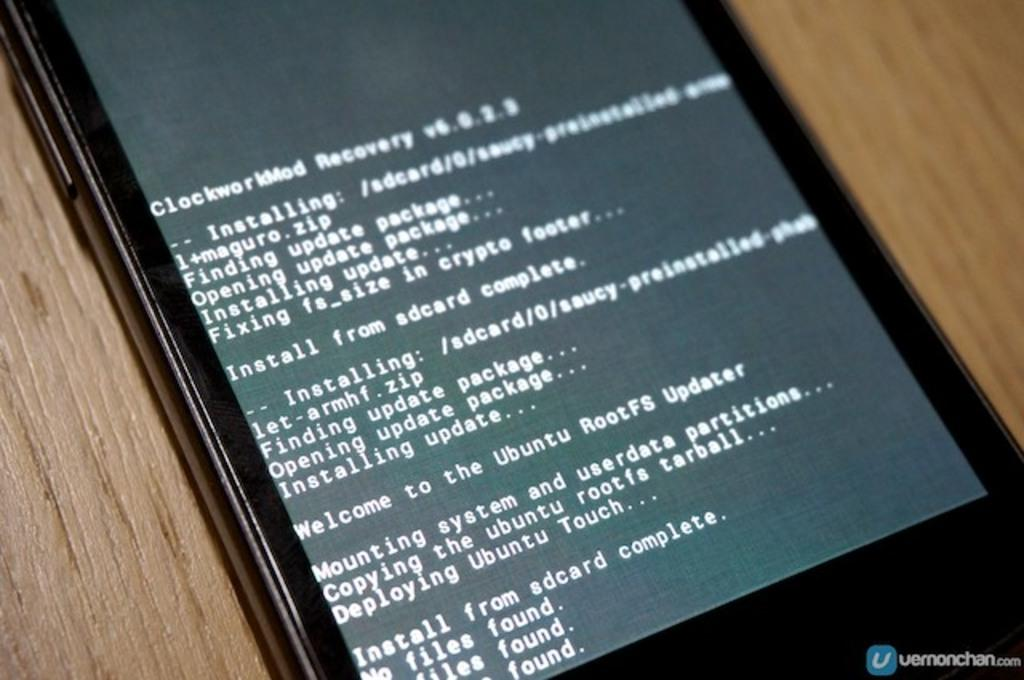<image>
Describe the image concisely. A smart device with error message on the screen starting with ClockworkMod Recovery at the top. 